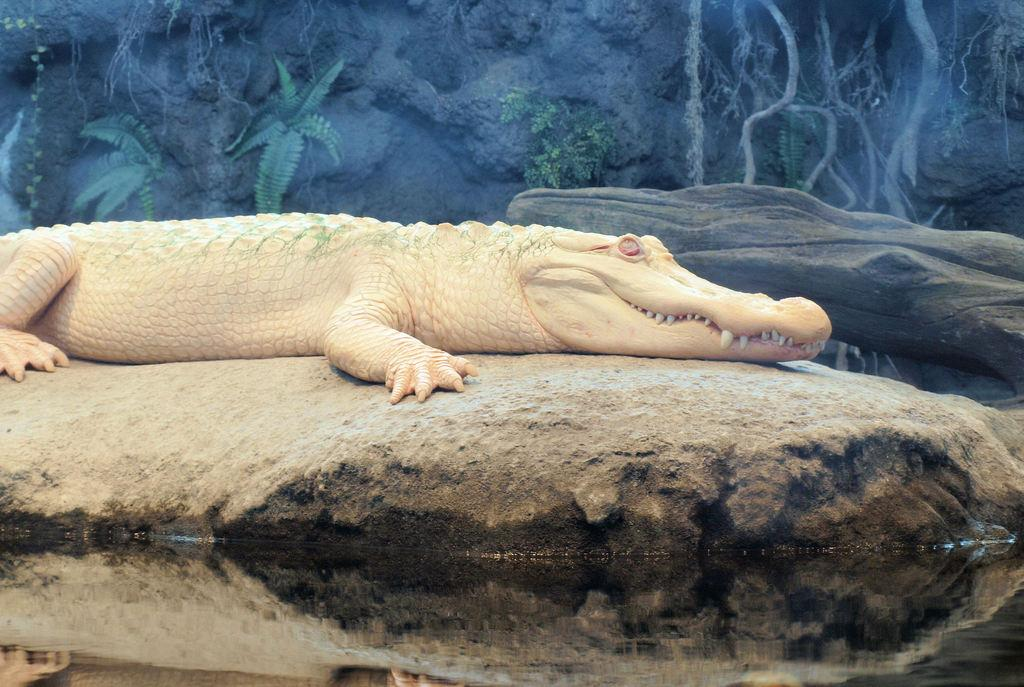What is the main subject of the image? There is a rock in the image. What is on the rock? There is a sculpture of a crocodile on the rock. Are there any other rocks visible in the image? Yes, there is another rock visible at the top of the image. What can be seen on the rock at the top? Plants and threads are visible on the rock at the top. How does the rock participate in the game shown in the image? There is no game present in the image; it features a rock with a crocodile sculpture and another rock with plants and threads. 